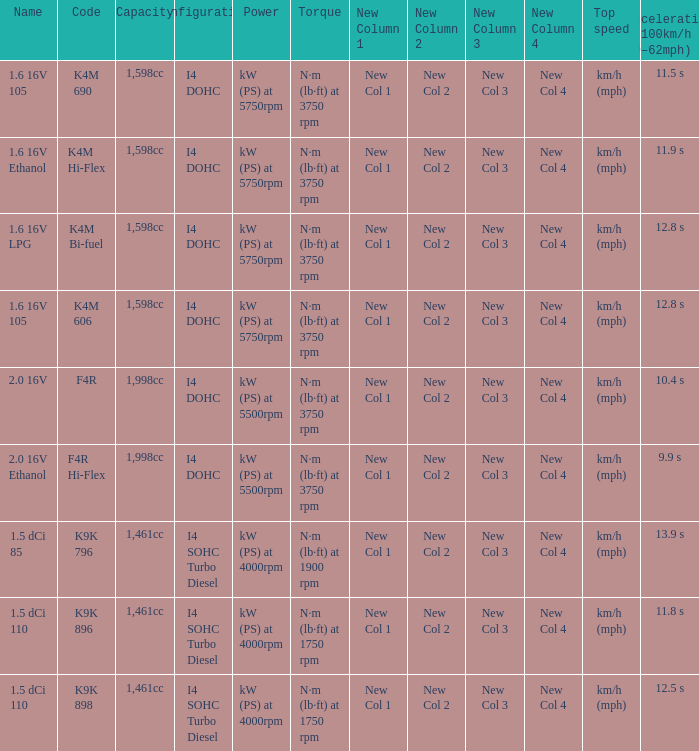Could you parse the entire table as a dict? {'header': ['Name', 'Code', 'Capacity', 'Configuration', 'Power', 'Torque', 'New Column 1', 'New Column 2', 'New Column 3', 'New Column 4', 'Top speed', 'Acceleration 0–100km/h (0–62mph)'], 'rows': [['1.6 16V 105', 'K4M 690', '1,598cc', 'I4 DOHC', 'kW (PS) at 5750rpm', 'N·m (lb·ft) at 3750 rpm', 'New Col 1', 'New Col 2', 'New Col 3', 'New Col 4', 'km/h (mph)', '11.5 s'], ['1.6 16V Ethanol', 'K4M Hi-Flex', '1,598cc', 'I4 DOHC', 'kW (PS) at 5750rpm', 'N·m (lb·ft) at 3750 rpm', 'New Col 1', 'New Col 2', 'New Col 3', 'New Col 4', 'km/h (mph)', '11.9 s'], ['1.6 16V LPG', 'K4M Bi-fuel', '1,598cc', 'I4 DOHC', 'kW (PS) at 5750rpm', 'N·m (lb·ft) at 3750 rpm', 'New Col 1', 'New Col 2', 'New Col 3', 'New Col 4', 'km/h (mph)', '12.8 s'], ['1.6 16V 105', 'K4M 606', '1,598cc', 'I4 DOHC', 'kW (PS) at 5750rpm', 'N·m (lb·ft) at 3750 rpm', 'New Col 1', 'New Col 2', 'New Col 3', 'New Col 4', 'km/h (mph)', '12.8 s'], ['2.0 16V', 'F4R', '1,998cc', 'I4 DOHC', 'kW (PS) at 5500rpm', 'N·m (lb·ft) at 3750 rpm', 'New Col 1', 'New Col 2', 'New Col 3', 'New Col 4', 'km/h (mph)', '10.4 s'], ['2.0 16V Ethanol', 'F4R Hi-Flex', '1,998cc', 'I4 DOHC', 'kW (PS) at 5500rpm', 'N·m (lb·ft) at 3750 rpm', 'New Col 1', 'New Col 2', 'New Col 3', 'New Col 4', 'km/h (mph)', '9.9 s'], ['1.5 dCi 85', 'K9K 796', '1,461cc', 'I4 SOHC Turbo Diesel', 'kW (PS) at 4000rpm', 'N·m (lb·ft) at 1900 rpm', 'New Col 1', 'New Col 2', 'New Col 3', 'New Col 4', 'km/h (mph)', '13.9 s'], ['1.5 dCi 110', 'K9K 896', '1,461cc', 'I4 SOHC Turbo Diesel', 'kW (PS) at 4000rpm', 'N·m (lb·ft) at 1750 rpm', 'New Col 1', 'New Col 2', 'New Col 3', 'New Col 4', 'km/h (mph)', '11.8 s'], ['1.5 dCi 110', 'K9K 898', '1,461cc', 'I4 SOHC Turbo Diesel', 'kW (PS) at 4000rpm', 'N·m (lb·ft) at 1750 rpm', 'New Col 1', 'New Col 2', 'New Col 3', 'New Col 4', 'km/h (mph)', '12.5 s']]} What is the code of 1.5 dci 110, which has a capacity of 1,461cc? K9K 896, K9K 898. 